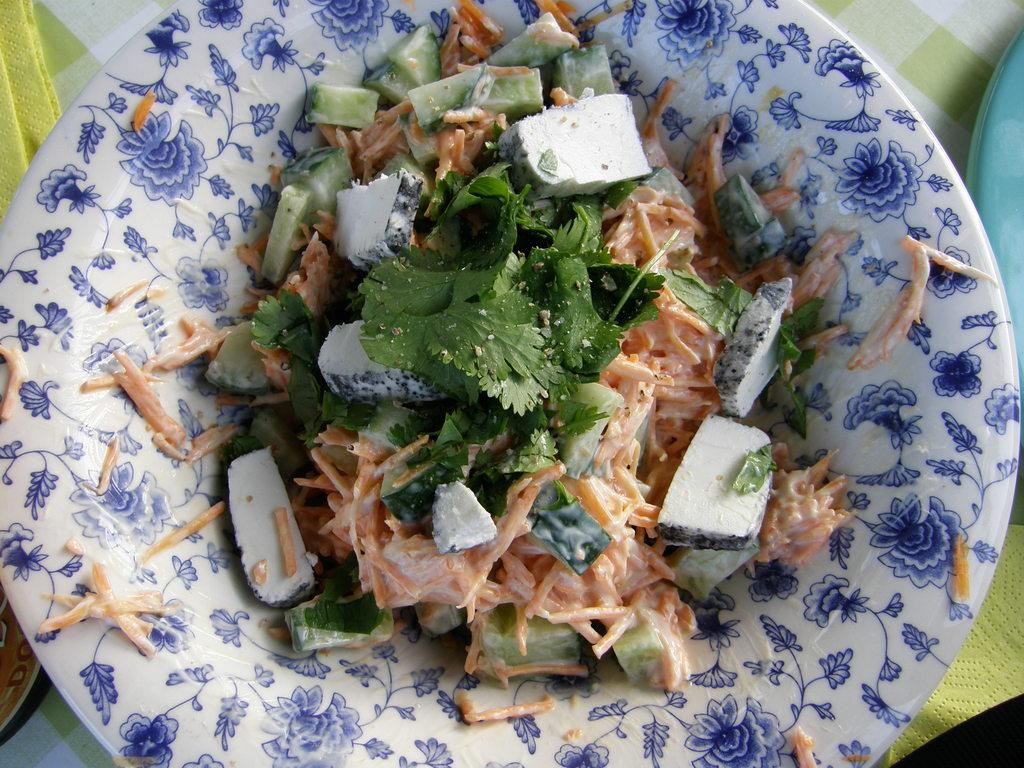What is on the white plate in the image? There are mint pieces, carrot pieces, and other vegetable pieces on the white plate in the image. Are there any other plates visible in the image? Yes, there is a blue plate in the image. What can be seen on the table in the image? There is a cloth on the table in the image. What type of caption is written on the blue plate in the image? There is no caption written on the blue plate in the image, as it is a plate and not a text-based item. 